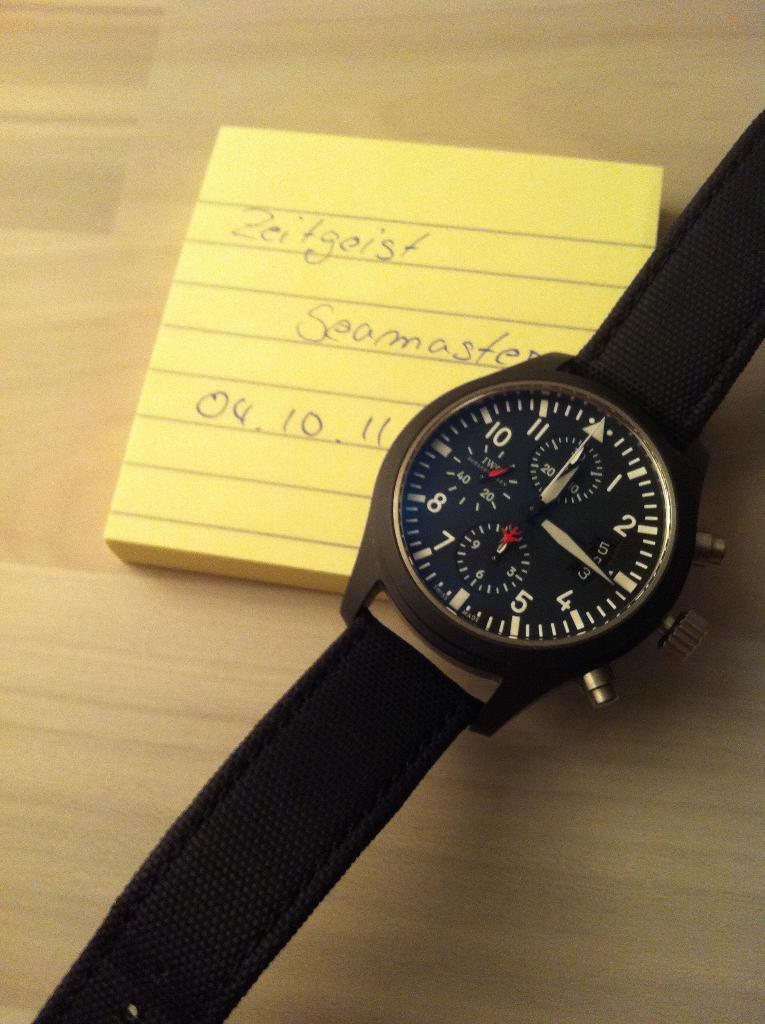<image>
Render a clear and concise summary of the photo. A wristwatch with a note saying Zeitgeist under it. 